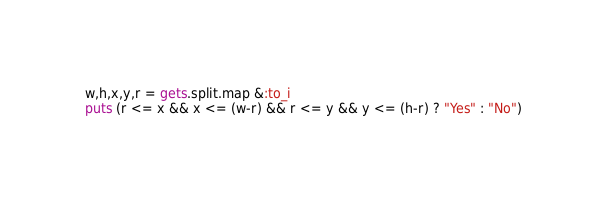Convert code to text. <code><loc_0><loc_0><loc_500><loc_500><_Ruby_>w,h,x,y,r = gets.split.map &:to_i
puts (r <= x && x <= (w-r) && r <= y && y <= (h-r) ? "Yes" : "No")

</code> 